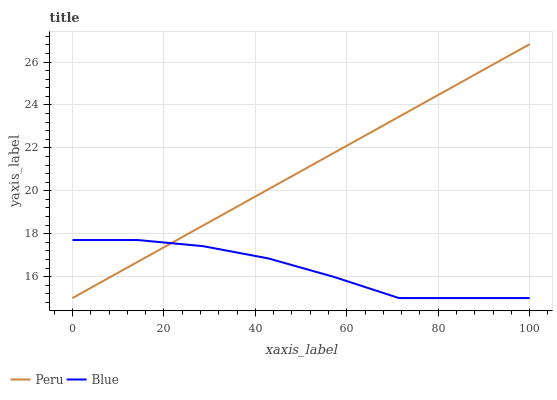Does Peru have the minimum area under the curve?
Answer yes or no. No. Is Peru the roughest?
Answer yes or no. No. 